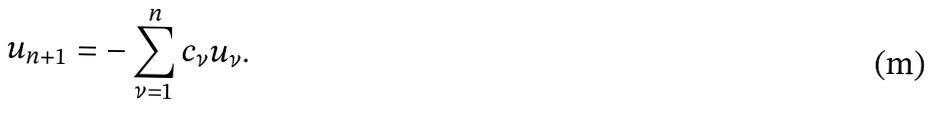<formula> <loc_0><loc_0><loc_500><loc_500>u _ { n + 1 } = - \sum _ { \nu = 1 } ^ { n } c _ { \nu } u _ { \nu } .</formula> 